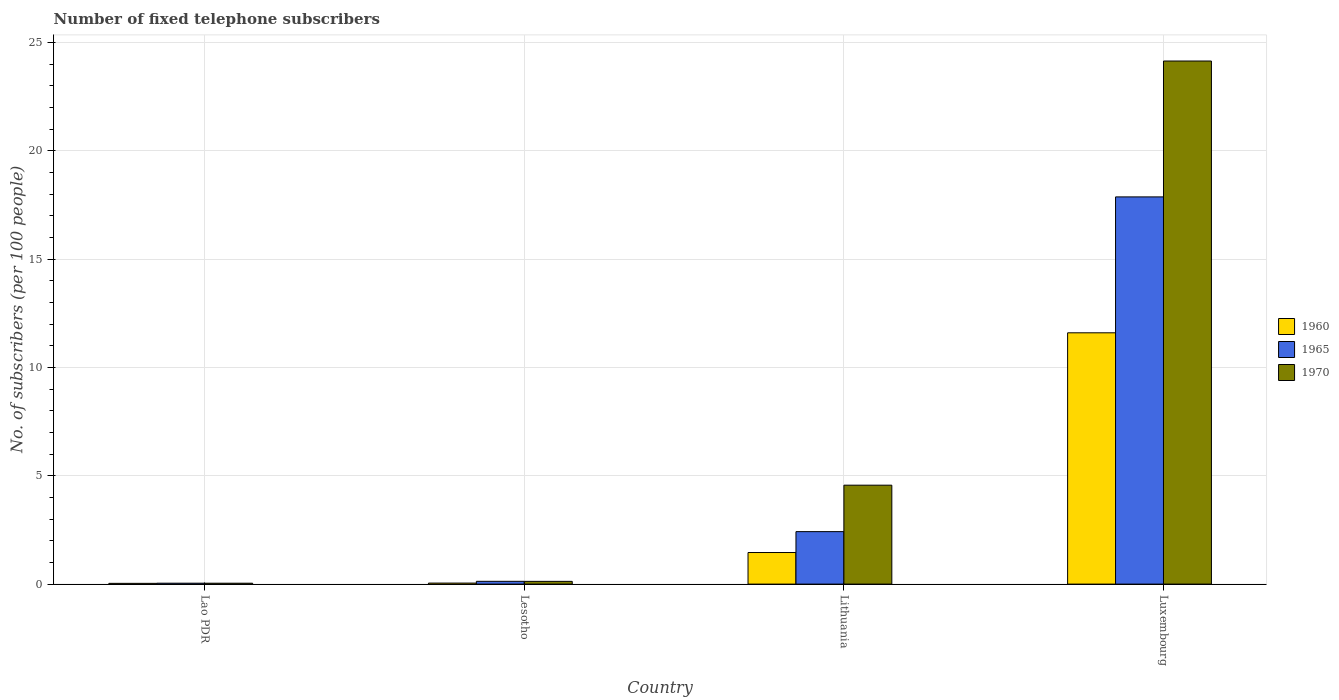How many different coloured bars are there?
Provide a short and direct response. 3. Are the number of bars on each tick of the X-axis equal?
Provide a short and direct response. Yes. How many bars are there on the 3rd tick from the right?
Offer a very short reply. 3. What is the label of the 1st group of bars from the left?
Keep it short and to the point. Lao PDR. In how many cases, is the number of bars for a given country not equal to the number of legend labels?
Keep it short and to the point. 0. What is the number of fixed telephone subscribers in 1965 in Lao PDR?
Give a very brief answer. 0.04. Across all countries, what is the maximum number of fixed telephone subscribers in 1965?
Provide a succinct answer. 17.87. Across all countries, what is the minimum number of fixed telephone subscribers in 1965?
Make the answer very short. 0.04. In which country was the number of fixed telephone subscribers in 1970 maximum?
Your response must be concise. Luxembourg. In which country was the number of fixed telephone subscribers in 1960 minimum?
Give a very brief answer. Lao PDR. What is the total number of fixed telephone subscribers in 1970 in the graph?
Keep it short and to the point. 28.87. What is the difference between the number of fixed telephone subscribers in 1960 in Lao PDR and that in Lithuania?
Offer a terse response. -1.42. What is the difference between the number of fixed telephone subscribers in 1965 in Luxembourg and the number of fixed telephone subscribers in 1960 in Lithuania?
Keep it short and to the point. 16.41. What is the average number of fixed telephone subscribers in 1970 per country?
Keep it short and to the point. 7.22. What is the difference between the number of fixed telephone subscribers of/in 1965 and number of fixed telephone subscribers of/in 1970 in Lesotho?
Provide a succinct answer. 0. In how many countries, is the number of fixed telephone subscribers in 1960 greater than 20?
Your answer should be compact. 0. What is the ratio of the number of fixed telephone subscribers in 1970 in Lesotho to that in Lithuania?
Ensure brevity in your answer.  0.03. Is the number of fixed telephone subscribers in 1960 in Lao PDR less than that in Lithuania?
Your answer should be compact. Yes. Is the difference between the number of fixed telephone subscribers in 1965 in Lao PDR and Luxembourg greater than the difference between the number of fixed telephone subscribers in 1970 in Lao PDR and Luxembourg?
Your response must be concise. Yes. What is the difference between the highest and the second highest number of fixed telephone subscribers in 1965?
Make the answer very short. -17.74. What is the difference between the highest and the lowest number of fixed telephone subscribers in 1960?
Your answer should be very brief. 11.56. Is the sum of the number of fixed telephone subscribers in 1965 in Lao PDR and Lesotho greater than the maximum number of fixed telephone subscribers in 1970 across all countries?
Ensure brevity in your answer.  No. What does the 3rd bar from the left in Lao PDR represents?
Your answer should be compact. 1970. What does the 2nd bar from the right in Luxembourg represents?
Offer a terse response. 1965. What is the difference between two consecutive major ticks on the Y-axis?
Give a very brief answer. 5. Are the values on the major ticks of Y-axis written in scientific E-notation?
Make the answer very short. No. Does the graph contain grids?
Provide a succinct answer. Yes. How many legend labels are there?
Offer a very short reply. 3. What is the title of the graph?
Offer a very short reply. Number of fixed telephone subscribers. What is the label or title of the Y-axis?
Provide a succinct answer. No. of subscribers (per 100 people). What is the No. of subscribers (per 100 people) of 1960 in Lao PDR?
Give a very brief answer. 0.03. What is the No. of subscribers (per 100 people) in 1965 in Lao PDR?
Make the answer very short. 0.04. What is the No. of subscribers (per 100 people) in 1970 in Lao PDR?
Give a very brief answer. 0.04. What is the No. of subscribers (per 100 people) in 1960 in Lesotho?
Your answer should be compact. 0.05. What is the No. of subscribers (per 100 people) in 1965 in Lesotho?
Provide a short and direct response. 0.13. What is the No. of subscribers (per 100 people) of 1970 in Lesotho?
Give a very brief answer. 0.13. What is the No. of subscribers (per 100 people) of 1960 in Lithuania?
Ensure brevity in your answer.  1.46. What is the No. of subscribers (per 100 people) of 1965 in Lithuania?
Give a very brief answer. 2.42. What is the No. of subscribers (per 100 people) of 1970 in Lithuania?
Provide a short and direct response. 4.57. What is the No. of subscribers (per 100 people) of 1960 in Luxembourg?
Make the answer very short. 11.6. What is the No. of subscribers (per 100 people) of 1965 in Luxembourg?
Ensure brevity in your answer.  17.87. What is the No. of subscribers (per 100 people) of 1970 in Luxembourg?
Your answer should be compact. 24.14. Across all countries, what is the maximum No. of subscribers (per 100 people) in 1960?
Your response must be concise. 11.6. Across all countries, what is the maximum No. of subscribers (per 100 people) of 1965?
Make the answer very short. 17.87. Across all countries, what is the maximum No. of subscribers (per 100 people) in 1970?
Your answer should be compact. 24.14. Across all countries, what is the minimum No. of subscribers (per 100 people) in 1960?
Provide a succinct answer. 0.03. Across all countries, what is the minimum No. of subscribers (per 100 people) in 1965?
Your answer should be very brief. 0.04. Across all countries, what is the minimum No. of subscribers (per 100 people) of 1970?
Offer a terse response. 0.04. What is the total No. of subscribers (per 100 people) in 1960 in the graph?
Make the answer very short. 13.14. What is the total No. of subscribers (per 100 people) in 1965 in the graph?
Ensure brevity in your answer.  20.46. What is the total No. of subscribers (per 100 people) of 1970 in the graph?
Offer a terse response. 28.87. What is the difference between the No. of subscribers (per 100 people) in 1960 in Lao PDR and that in Lesotho?
Offer a very short reply. -0.01. What is the difference between the No. of subscribers (per 100 people) in 1965 in Lao PDR and that in Lesotho?
Give a very brief answer. -0.09. What is the difference between the No. of subscribers (per 100 people) in 1970 in Lao PDR and that in Lesotho?
Keep it short and to the point. -0.09. What is the difference between the No. of subscribers (per 100 people) of 1960 in Lao PDR and that in Lithuania?
Make the answer very short. -1.42. What is the difference between the No. of subscribers (per 100 people) of 1965 in Lao PDR and that in Lithuania?
Offer a very short reply. -2.38. What is the difference between the No. of subscribers (per 100 people) in 1970 in Lao PDR and that in Lithuania?
Provide a short and direct response. -4.52. What is the difference between the No. of subscribers (per 100 people) in 1960 in Lao PDR and that in Luxembourg?
Your answer should be very brief. -11.56. What is the difference between the No. of subscribers (per 100 people) in 1965 in Lao PDR and that in Luxembourg?
Provide a short and direct response. -17.83. What is the difference between the No. of subscribers (per 100 people) of 1970 in Lao PDR and that in Luxembourg?
Keep it short and to the point. -24.1. What is the difference between the No. of subscribers (per 100 people) in 1960 in Lesotho and that in Lithuania?
Give a very brief answer. -1.41. What is the difference between the No. of subscribers (per 100 people) of 1965 in Lesotho and that in Lithuania?
Your answer should be compact. -2.29. What is the difference between the No. of subscribers (per 100 people) of 1970 in Lesotho and that in Lithuania?
Provide a short and direct response. -4.44. What is the difference between the No. of subscribers (per 100 people) in 1960 in Lesotho and that in Luxembourg?
Your response must be concise. -11.55. What is the difference between the No. of subscribers (per 100 people) of 1965 in Lesotho and that in Luxembourg?
Your answer should be compact. -17.74. What is the difference between the No. of subscribers (per 100 people) in 1970 in Lesotho and that in Luxembourg?
Your answer should be compact. -24.01. What is the difference between the No. of subscribers (per 100 people) in 1960 in Lithuania and that in Luxembourg?
Your response must be concise. -10.14. What is the difference between the No. of subscribers (per 100 people) in 1965 in Lithuania and that in Luxembourg?
Your answer should be compact. -15.45. What is the difference between the No. of subscribers (per 100 people) of 1970 in Lithuania and that in Luxembourg?
Keep it short and to the point. -19.58. What is the difference between the No. of subscribers (per 100 people) of 1960 in Lao PDR and the No. of subscribers (per 100 people) of 1965 in Lesotho?
Provide a succinct answer. -0.09. What is the difference between the No. of subscribers (per 100 people) in 1960 in Lao PDR and the No. of subscribers (per 100 people) in 1970 in Lesotho?
Your answer should be very brief. -0.09. What is the difference between the No. of subscribers (per 100 people) of 1965 in Lao PDR and the No. of subscribers (per 100 people) of 1970 in Lesotho?
Offer a terse response. -0.08. What is the difference between the No. of subscribers (per 100 people) in 1960 in Lao PDR and the No. of subscribers (per 100 people) in 1965 in Lithuania?
Ensure brevity in your answer.  -2.39. What is the difference between the No. of subscribers (per 100 people) in 1960 in Lao PDR and the No. of subscribers (per 100 people) in 1970 in Lithuania?
Your answer should be very brief. -4.53. What is the difference between the No. of subscribers (per 100 people) in 1965 in Lao PDR and the No. of subscribers (per 100 people) in 1970 in Lithuania?
Your answer should be compact. -4.52. What is the difference between the No. of subscribers (per 100 people) of 1960 in Lao PDR and the No. of subscribers (per 100 people) of 1965 in Luxembourg?
Provide a short and direct response. -17.84. What is the difference between the No. of subscribers (per 100 people) in 1960 in Lao PDR and the No. of subscribers (per 100 people) in 1970 in Luxembourg?
Give a very brief answer. -24.11. What is the difference between the No. of subscribers (per 100 people) of 1965 in Lao PDR and the No. of subscribers (per 100 people) of 1970 in Luxembourg?
Make the answer very short. -24.1. What is the difference between the No. of subscribers (per 100 people) in 1960 in Lesotho and the No. of subscribers (per 100 people) in 1965 in Lithuania?
Keep it short and to the point. -2.37. What is the difference between the No. of subscribers (per 100 people) in 1960 in Lesotho and the No. of subscribers (per 100 people) in 1970 in Lithuania?
Offer a terse response. -4.52. What is the difference between the No. of subscribers (per 100 people) of 1965 in Lesotho and the No. of subscribers (per 100 people) of 1970 in Lithuania?
Provide a succinct answer. -4.44. What is the difference between the No. of subscribers (per 100 people) of 1960 in Lesotho and the No. of subscribers (per 100 people) of 1965 in Luxembourg?
Provide a succinct answer. -17.82. What is the difference between the No. of subscribers (per 100 people) in 1960 in Lesotho and the No. of subscribers (per 100 people) in 1970 in Luxembourg?
Your answer should be very brief. -24.09. What is the difference between the No. of subscribers (per 100 people) of 1965 in Lesotho and the No. of subscribers (per 100 people) of 1970 in Luxembourg?
Give a very brief answer. -24.01. What is the difference between the No. of subscribers (per 100 people) in 1960 in Lithuania and the No. of subscribers (per 100 people) in 1965 in Luxembourg?
Offer a very short reply. -16.41. What is the difference between the No. of subscribers (per 100 people) of 1960 in Lithuania and the No. of subscribers (per 100 people) of 1970 in Luxembourg?
Ensure brevity in your answer.  -22.68. What is the difference between the No. of subscribers (per 100 people) of 1965 in Lithuania and the No. of subscribers (per 100 people) of 1970 in Luxembourg?
Offer a very short reply. -21.72. What is the average No. of subscribers (per 100 people) in 1960 per country?
Give a very brief answer. 3.28. What is the average No. of subscribers (per 100 people) of 1965 per country?
Offer a terse response. 5.12. What is the average No. of subscribers (per 100 people) of 1970 per country?
Your answer should be very brief. 7.22. What is the difference between the No. of subscribers (per 100 people) in 1960 and No. of subscribers (per 100 people) in 1965 in Lao PDR?
Keep it short and to the point. -0.01. What is the difference between the No. of subscribers (per 100 people) in 1960 and No. of subscribers (per 100 people) in 1970 in Lao PDR?
Your answer should be compact. -0.01. What is the difference between the No. of subscribers (per 100 people) in 1965 and No. of subscribers (per 100 people) in 1970 in Lao PDR?
Your answer should be compact. 0. What is the difference between the No. of subscribers (per 100 people) of 1960 and No. of subscribers (per 100 people) of 1965 in Lesotho?
Provide a succinct answer. -0.08. What is the difference between the No. of subscribers (per 100 people) in 1960 and No. of subscribers (per 100 people) in 1970 in Lesotho?
Give a very brief answer. -0.08. What is the difference between the No. of subscribers (per 100 people) in 1965 and No. of subscribers (per 100 people) in 1970 in Lesotho?
Your response must be concise. 0. What is the difference between the No. of subscribers (per 100 people) of 1960 and No. of subscribers (per 100 people) of 1965 in Lithuania?
Ensure brevity in your answer.  -0.96. What is the difference between the No. of subscribers (per 100 people) in 1960 and No. of subscribers (per 100 people) in 1970 in Lithuania?
Your answer should be compact. -3.11. What is the difference between the No. of subscribers (per 100 people) of 1965 and No. of subscribers (per 100 people) of 1970 in Lithuania?
Make the answer very short. -2.14. What is the difference between the No. of subscribers (per 100 people) of 1960 and No. of subscribers (per 100 people) of 1965 in Luxembourg?
Offer a terse response. -6.27. What is the difference between the No. of subscribers (per 100 people) in 1960 and No. of subscribers (per 100 people) in 1970 in Luxembourg?
Your answer should be compact. -12.54. What is the difference between the No. of subscribers (per 100 people) in 1965 and No. of subscribers (per 100 people) in 1970 in Luxembourg?
Offer a terse response. -6.27. What is the ratio of the No. of subscribers (per 100 people) of 1960 in Lao PDR to that in Lesotho?
Give a very brief answer. 0.74. What is the ratio of the No. of subscribers (per 100 people) of 1965 in Lao PDR to that in Lesotho?
Offer a very short reply. 0.33. What is the ratio of the No. of subscribers (per 100 people) of 1970 in Lao PDR to that in Lesotho?
Offer a terse response. 0.33. What is the ratio of the No. of subscribers (per 100 people) in 1960 in Lao PDR to that in Lithuania?
Your response must be concise. 0.02. What is the ratio of the No. of subscribers (per 100 people) of 1965 in Lao PDR to that in Lithuania?
Give a very brief answer. 0.02. What is the ratio of the No. of subscribers (per 100 people) in 1970 in Lao PDR to that in Lithuania?
Ensure brevity in your answer.  0.01. What is the ratio of the No. of subscribers (per 100 people) of 1960 in Lao PDR to that in Luxembourg?
Make the answer very short. 0. What is the ratio of the No. of subscribers (per 100 people) of 1965 in Lao PDR to that in Luxembourg?
Provide a succinct answer. 0. What is the ratio of the No. of subscribers (per 100 people) of 1970 in Lao PDR to that in Luxembourg?
Offer a terse response. 0. What is the ratio of the No. of subscribers (per 100 people) of 1960 in Lesotho to that in Lithuania?
Provide a succinct answer. 0.03. What is the ratio of the No. of subscribers (per 100 people) in 1965 in Lesotho to that in Lithuania?
Your answer should be very brief. 0.05. What is the ratio of the No. of subscribers (per 100 people) of 1970 in Lesotho to that in Lithuania?
Your answer should be compact. 0.03. What is the ratio of the No. of subscribers (per 100 people) in 1960 in Lesotho to that in Luxembourg?
Your response must be concise. 0. What is the ratio of the No. of subscribers (per 100 people) of 1965 in Lesotho to that in Luxembourg?
Offer a very short reply. 0.01. What is the ratio of the No. of subscribers (per 100 people) in 1970 in Lesotho to that in Luxembourg?
Your answer should be very brief. 0.01. What is the ratio of the No. of subscribers (per 100 people) of 1960 in Lithuania to that in Luxembourg?
Your response must be concise. 0.13. What is the ratio of the No. of subscribers (per 100 people) of 1965 in Lithuania to that in Luxembourg?
Offer a terse response. 0.14. What is the ratio of the No. of subscribers (per 100 people) in 1970 in Lithuania to that in Luxembourg?
Ensure brevity in your answer.  0.19. What is the difference between the highest and the second highest No. of subscribers (per 100 people) of 1960?
Give a very brief answer. 10.14. What is the difference between the highest and the second highest No. of subscribers (per 100 people) of 1965?
Provide a short and direct response. 15.45. What is the difference between the highest and the second highest No. of subscribers (per 100 people) of 1970?
Give a very brief answer. 19.58. What is the difference between the highest and the lowest No. of subscribers (per 100 people) of 1960?
Ensure brevity in your answer.  11.56. What is the difference between the highest and the lowest No. of subscribers (per 100 people) of 1965?
Ensure brevity in your answer.  17.83. What is the difference between the highest and the lowest No. of subscribers (per 100 people) of 1970?
Keep it short and to the point. 24.1. 